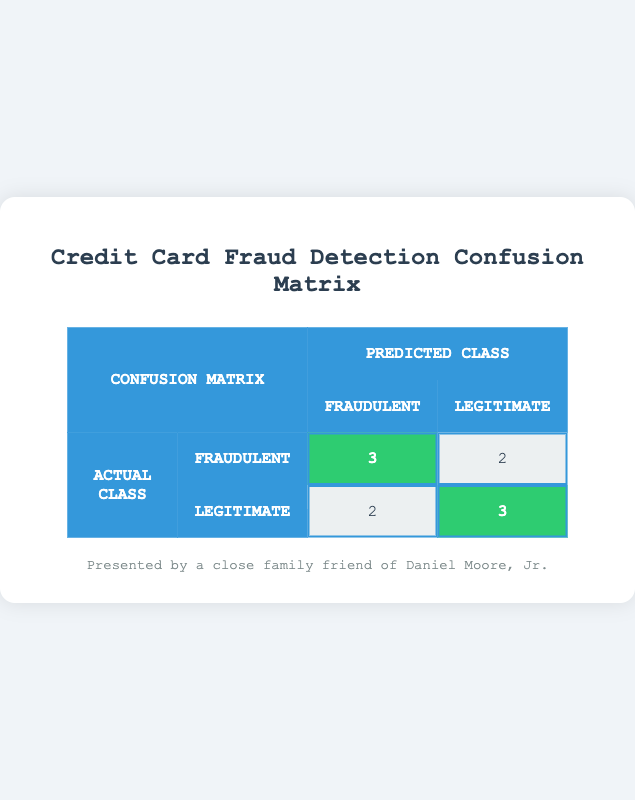What is the number of transactions classified as fraudulent and actually fraudulent? In the table, the entry for Actual Class "Fraudulent" and Predicted Class "Fraudulent" shows a value of 3. This means that there are 3 transactions that were correctly identified as fraudulent.
Answer: 3 What is the total number of legitimate transactions that were incorrectly predicted as fraudulent? In the table, under the Actual Class "Legitimate" and Predicted Class "Fraudulent," the value is 2. This indicates that 2 legitimate transactions were wrongly classified as fraudulent.
Answer: 2 How many total transactions are classified as legitimate? To find the number of legitimate transactions, look at the row for Actual Class "Legitimate." There are 3 transactions classified as legitimate and another 2 that were predicted as fraudulent. Therefore, total legitimate transactions = 3 + 2 = 5.
Answer: 5 Is it true that there are more fraudulent transactions predicted correctly than legitimate transactions predicted incorrectly? From the table, there are 3 correctly predicted fraudulent transactions and 2 incorrectly predicted legitimate transactions. Since 3 is greater than 2, the statement is true.
Answer: Yes What is the overall accuracy of the fraud detection model? The accuracy is calculated by taking the number of correct predictions (3 fraudulent + 3 legitimate = 6) divided by the total number of transactions (10). So, accuracy = 6/10 = 0.6, which is 60%.
Answer: 60% How many total transactions are identified as fraudulent in predictions? From the table, you add the values from the "Fraudulent" column: 3 (true fraudulent) + 2 (wrongly predicted legitimate) = 5. Thus, the total fraudulent predictions are 5.
Answer: 5 What is the difference between the number of true positives and false negatives? True positives (correctly predicted fraudulent) = 3, and false negatives (actual fraudulent but predicted as legitimate) = 2. The difference is 3 - 2 = 1, indicating there is 1 more true positive than false negative.
Answer: 1 How many transactions in total were categorized as fraudulent? From the table, looking at both predicted and actual classes, sum the values in the "Fraudulent" column: 3 (Fraudulent & Fraudulent) + 2 (Legitimate & Fraudulent) = 5. Therefore, a total of 5 transactions are categorized as fraudulent.
Answer: 5 What is the number of legitimate transactions correctly identified as legitimate? Referring to the table, the entry under Actual Class "Legitimate" and Predicted Class "Legitimate" shows a value of 3. Hence, 3 legitimate transactions were correctly classified as legitimate.
Answer: 3 What is the total count of transactions misclassified? Misclassified transactions include those under Actual Class "Fraudulent" but predicted as "Legitimate" (2) and those under Actual Class "Legitimate" but predicted as "Fraudulent" (2). So, total misclassified = 2 + 2 = 4.
Answer: 4 